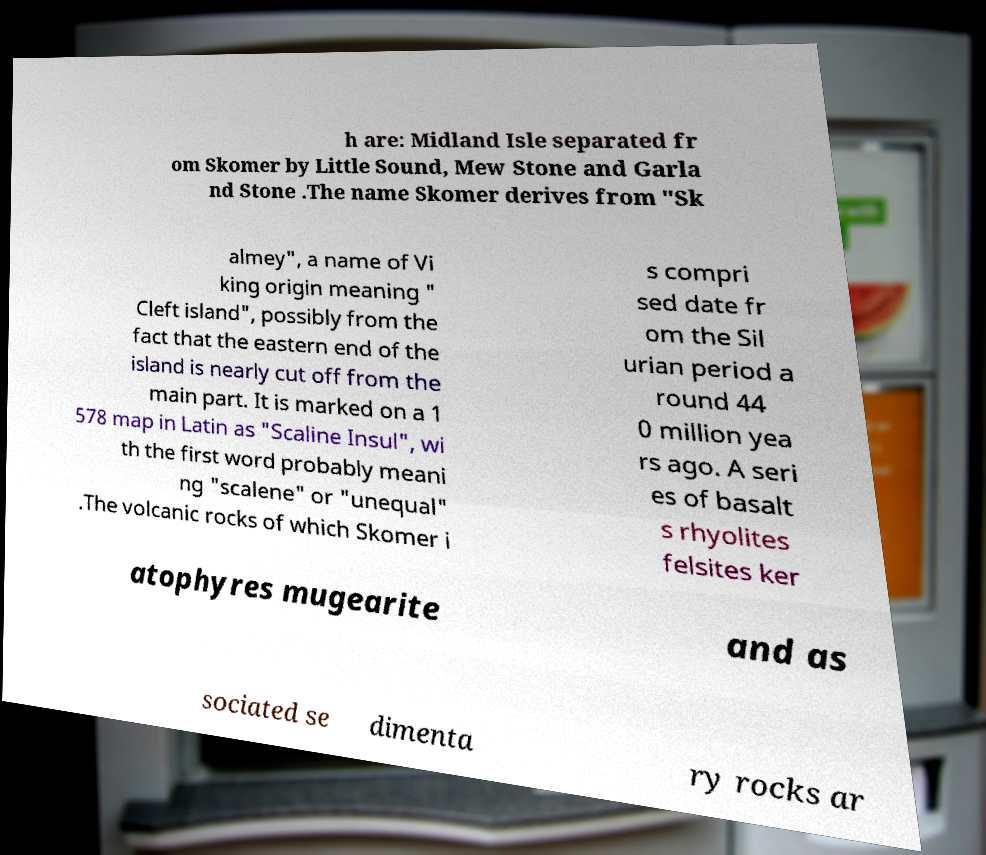Please read and relay the text visible in this image. What does it say? h are: Midland Isle separated fr om Skomer by Little Sound, Mew Stone and Garla nd Stone .The name Skomer derives from "Sk almey", a name of Vi king origin meaning " Cleft island", possibly from the fact that the eastern end of the island is nearly cut off from the main part. It is marked on a 1 578 map in Latin as "Scaline Insul", wi th the first word probably meani ng "scalene" or "unequal" .The volcanic rocks of which Skomer i s compri sed date fr om the Sil urian period a round 44 0 million yea rs ago. A seri es of basalt s rhyolites felsites ker atophyres mugearite and as sociated se dimenta ry rocks ar 